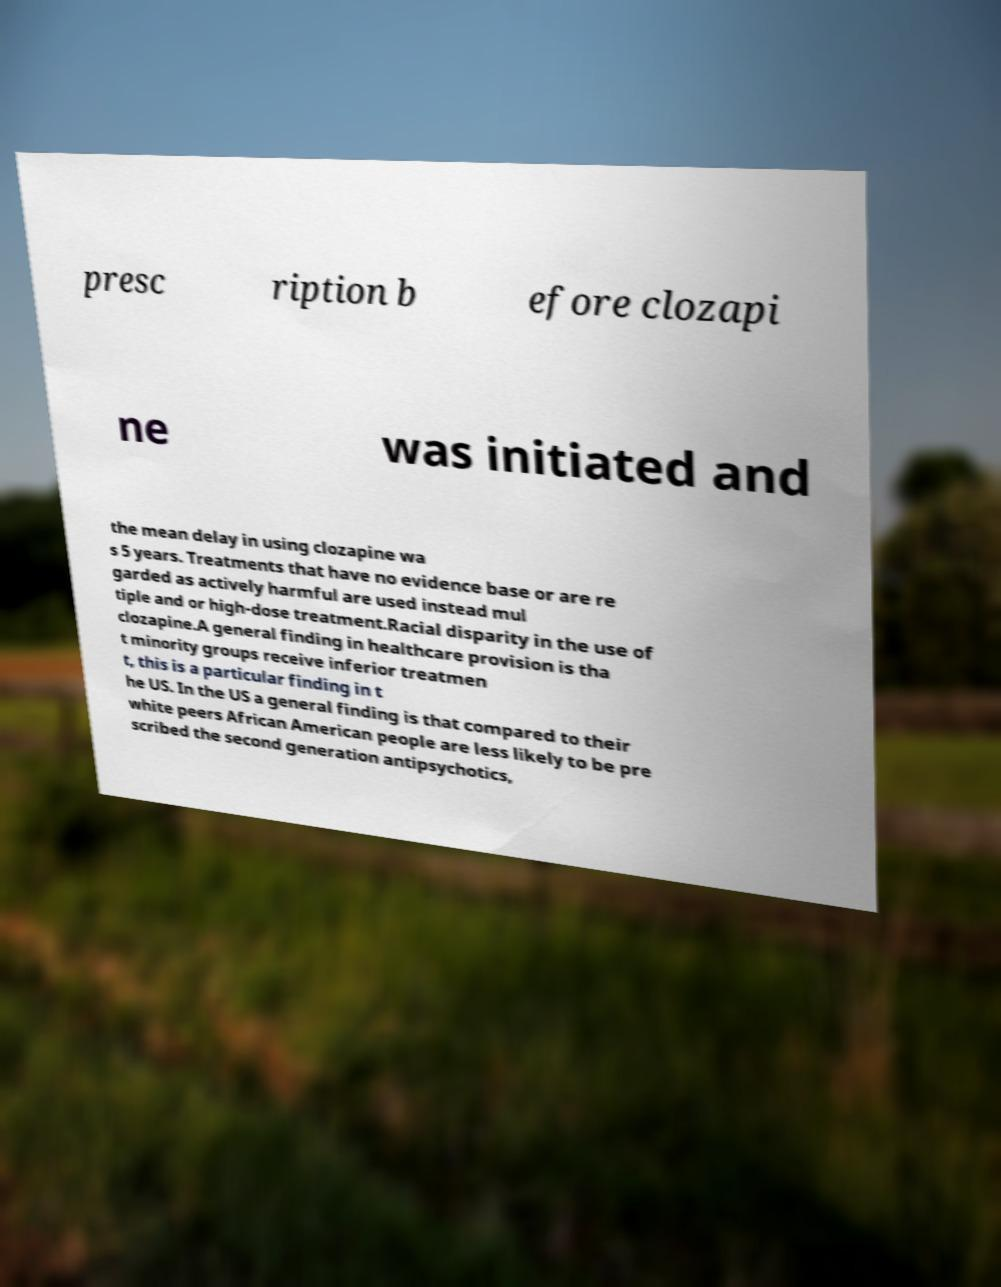Can you read and provide the text displayed in the image?This photo seems to have some interesting text. Can you extract and type it out for me? presc ription b efore clozapi ne was initiated and the mean delay in using clozapine wa s 5 years. Treatments that have no evidence base or are re garded as actively harmful are used instead mul tiple and or high-dose treatment.Racial disparity in the use of clozapine.A general finding in healthcare provision is tha t minority groups receive inferior treatmen t, this is a particular finding in t he US. In the US a general finding is that compared to their white peers African American people are less likely to be pre scribed the second generation antipsychotics, 